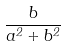Convert formula to latex. <formula><loc_0><loc_0><loc_500><loc_500>\frac { b } { a ^ { 2 } + b ^ { 2 } }</formula> 